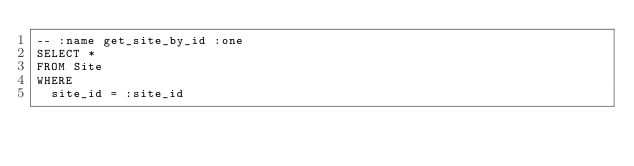Convert code to text. <code><loc_0><loc_0><loc_500><loc_500><_SQL_>-- :name get_site_by_id :one
SELECT *
FROM Site
WHERE
  site_id = :site_id
</code> 